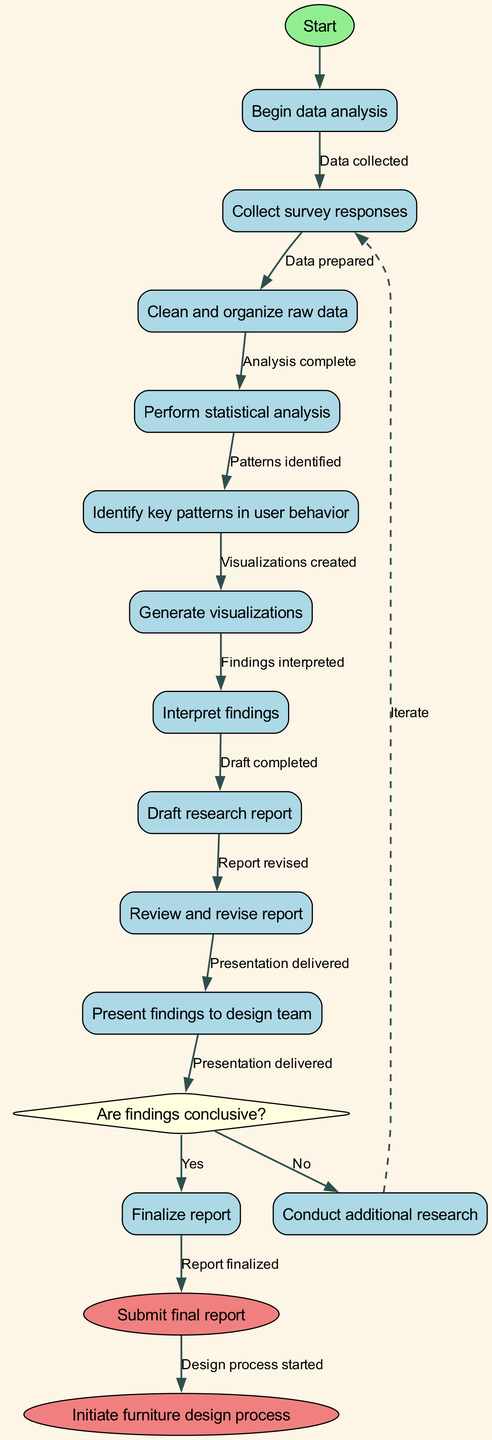What is the first activity in the diagram? The first activity following the start node is "Collect survey responses." This is the immediate next step in the flow of the activity diagram.
Answer: Collect survey responses How many activities are present in the diagram? There are eight activities listed in the diagram, which are performed consecutively.
Answer: Eight What decision point is present in the diagram? The decision point in the diagram is "Are findings conclusive?" This is where the flow can diverge based on the answer to this question.
Answer: Are findings conclusive? What happens if the findings are not conclusive? If the findings are not conclusive as indicated in the diagram, the process leads to "Conduct additional research." This is the action taken when the answer to the decision point is 'No'.
Answer: Conduct additional research What is the final outcome in the diagram following a 'Yes' decision? After a 'Yes' decision at the conclusive findings point, the final outcome represented is "Submit final report." This indicates the completion of the reporting process.
Answer: Submit final report How many edges are there in total connecting the nodes? There are 11 edges shown in the diagram that connect the various activities and outcomes sequentially.
Answer: Eleven What is the shape of the final nodes in the diagram? The final nodes, which represent the end of the process, are represented in the shape of ellipses, indicating the conclusion of the flow.
Answer: Ellipses Which activity directly precedes the decision node? The activity that directly precedes the decision node is "Draft research report." This is the last step before evaluating the findings.
Answer: Draft research report What is indicated by the edges connecting the nodes? The edges between the nodes illustrate the flow of the process, indicating the sequence and connections from one step to another throughout the analysis and reporting.
Answer: Flow of the process 